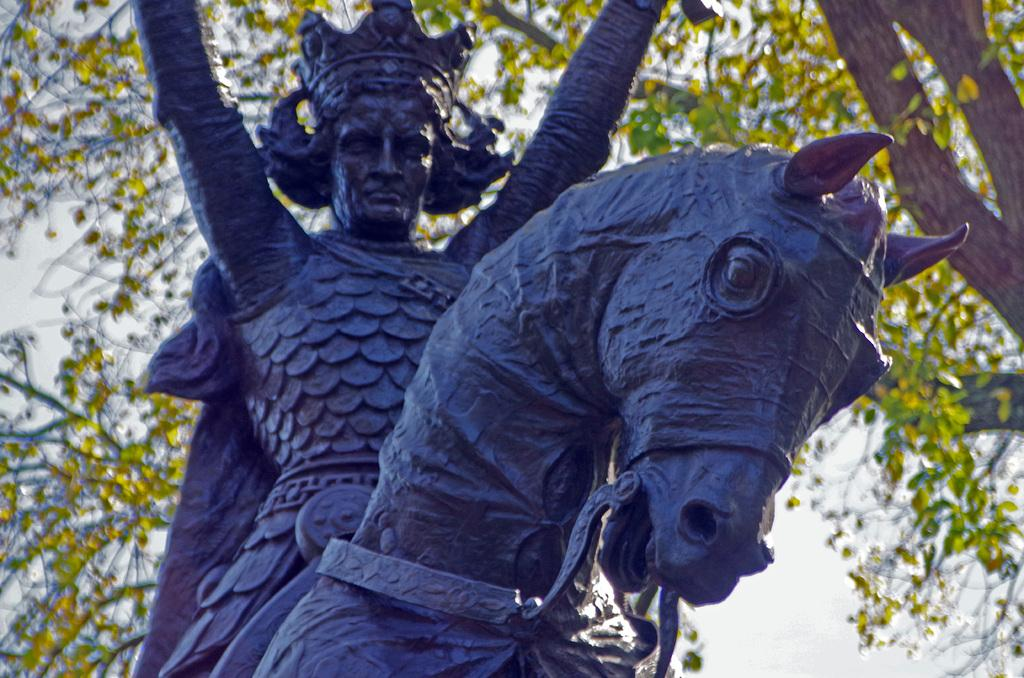What is the main subject of the image? There is a statue of a person sitting on a horse in the image. What can be seen in the background of the image? There are trees visible in the background of the image. What is visible at the top of the image? The sky is visible at the top of the image. Can you see any jelly floating in the lake in the image? There is no lake or jelly present in the image. What phase is the moon in the image? There is no moon visible in the image; only the statue, trees, and sky are present. 